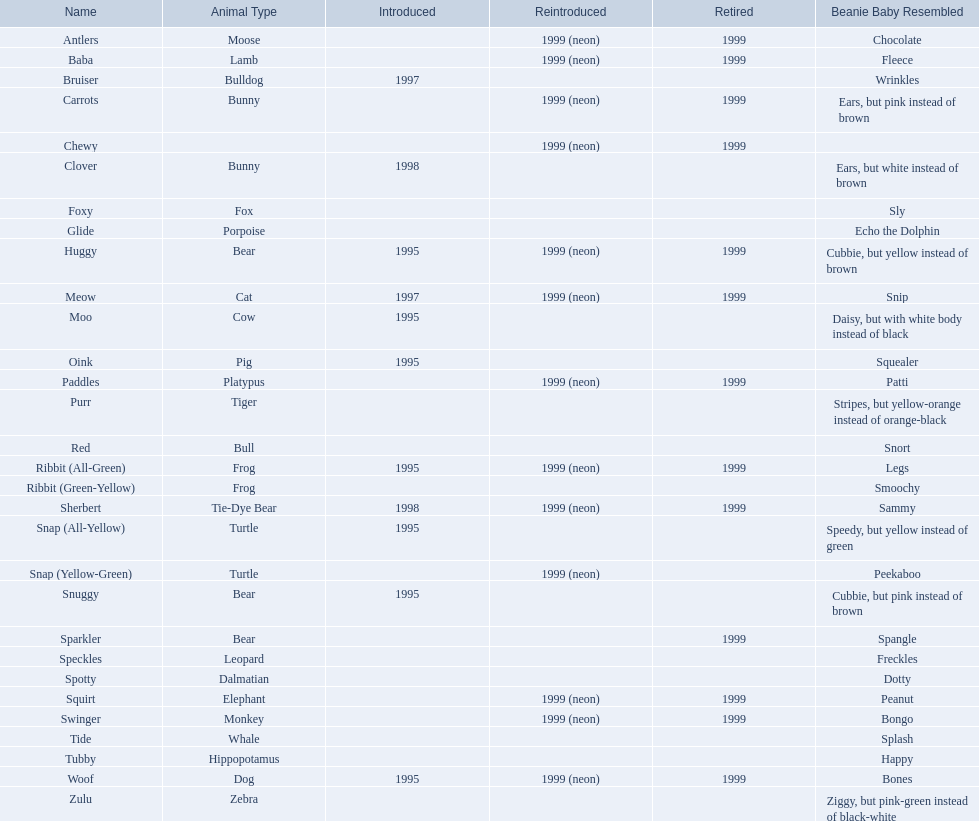Which creatures are considered pillow pals? Moose, Lamb, Bulldog, Bunny, Bunny, Fox, Porpoise, Bear, Cat, Cow, Pig, Platypus, Tiger, Bull, Frog, Frog, Tie-Dye Bear, Turtle, Turtle, Bear, Bear, Leopard, Dalmatian, Elephant, Monkey, Whale, Hippopotamus, Dog, Zebra. What is the dalmatian's moniker? Spotty. 